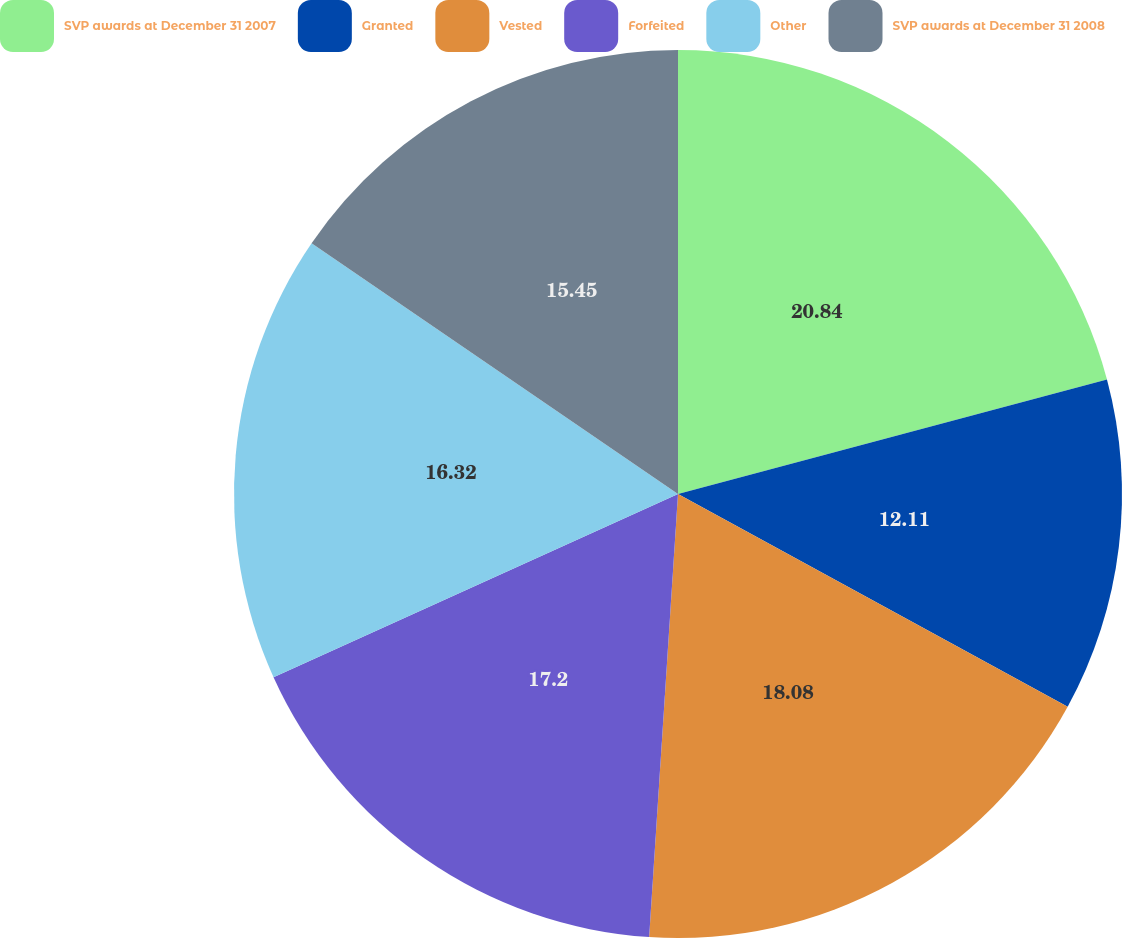Convert chart. <chart><loc_0><loc_0><loc_500><loc_500><pie_chart><fcel>SVP awards at December 31 2007<fcel>Granted<fcel>Vested<fcel>Forfeited<fcel>Other<fcel>SVP awards at December 31 2008<nl><fcel>20.85%<fcel>12.11%<fcel>18.08%<fcel>17.2%<fcel>16.32%<fcel>15.45%<nl></chart> 